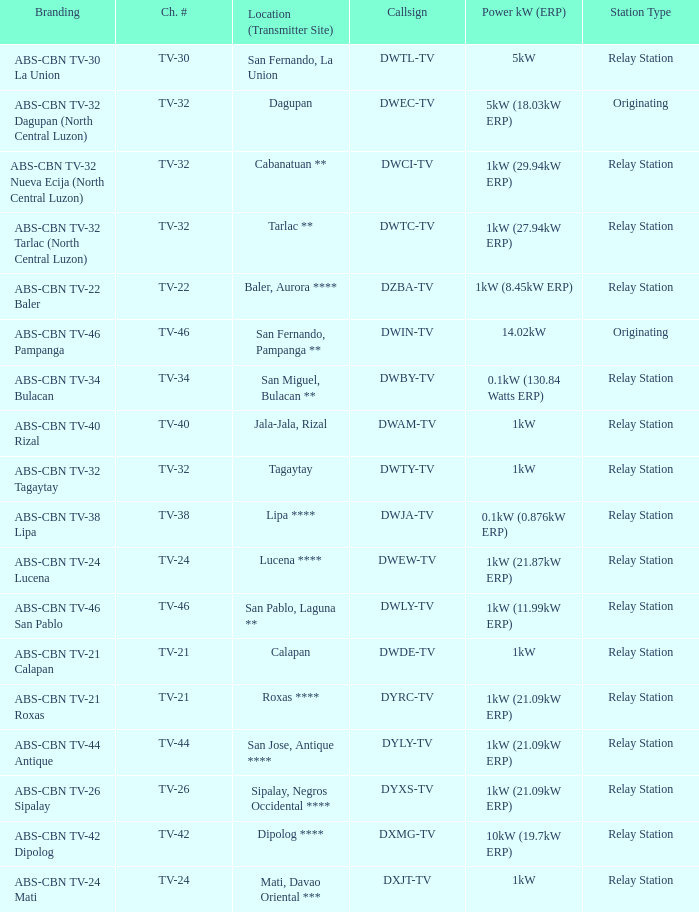What is the branding of the callsign DWCI-TV? ABS-CBN TV-32 Nueva Ecija (North Central Luzon). 